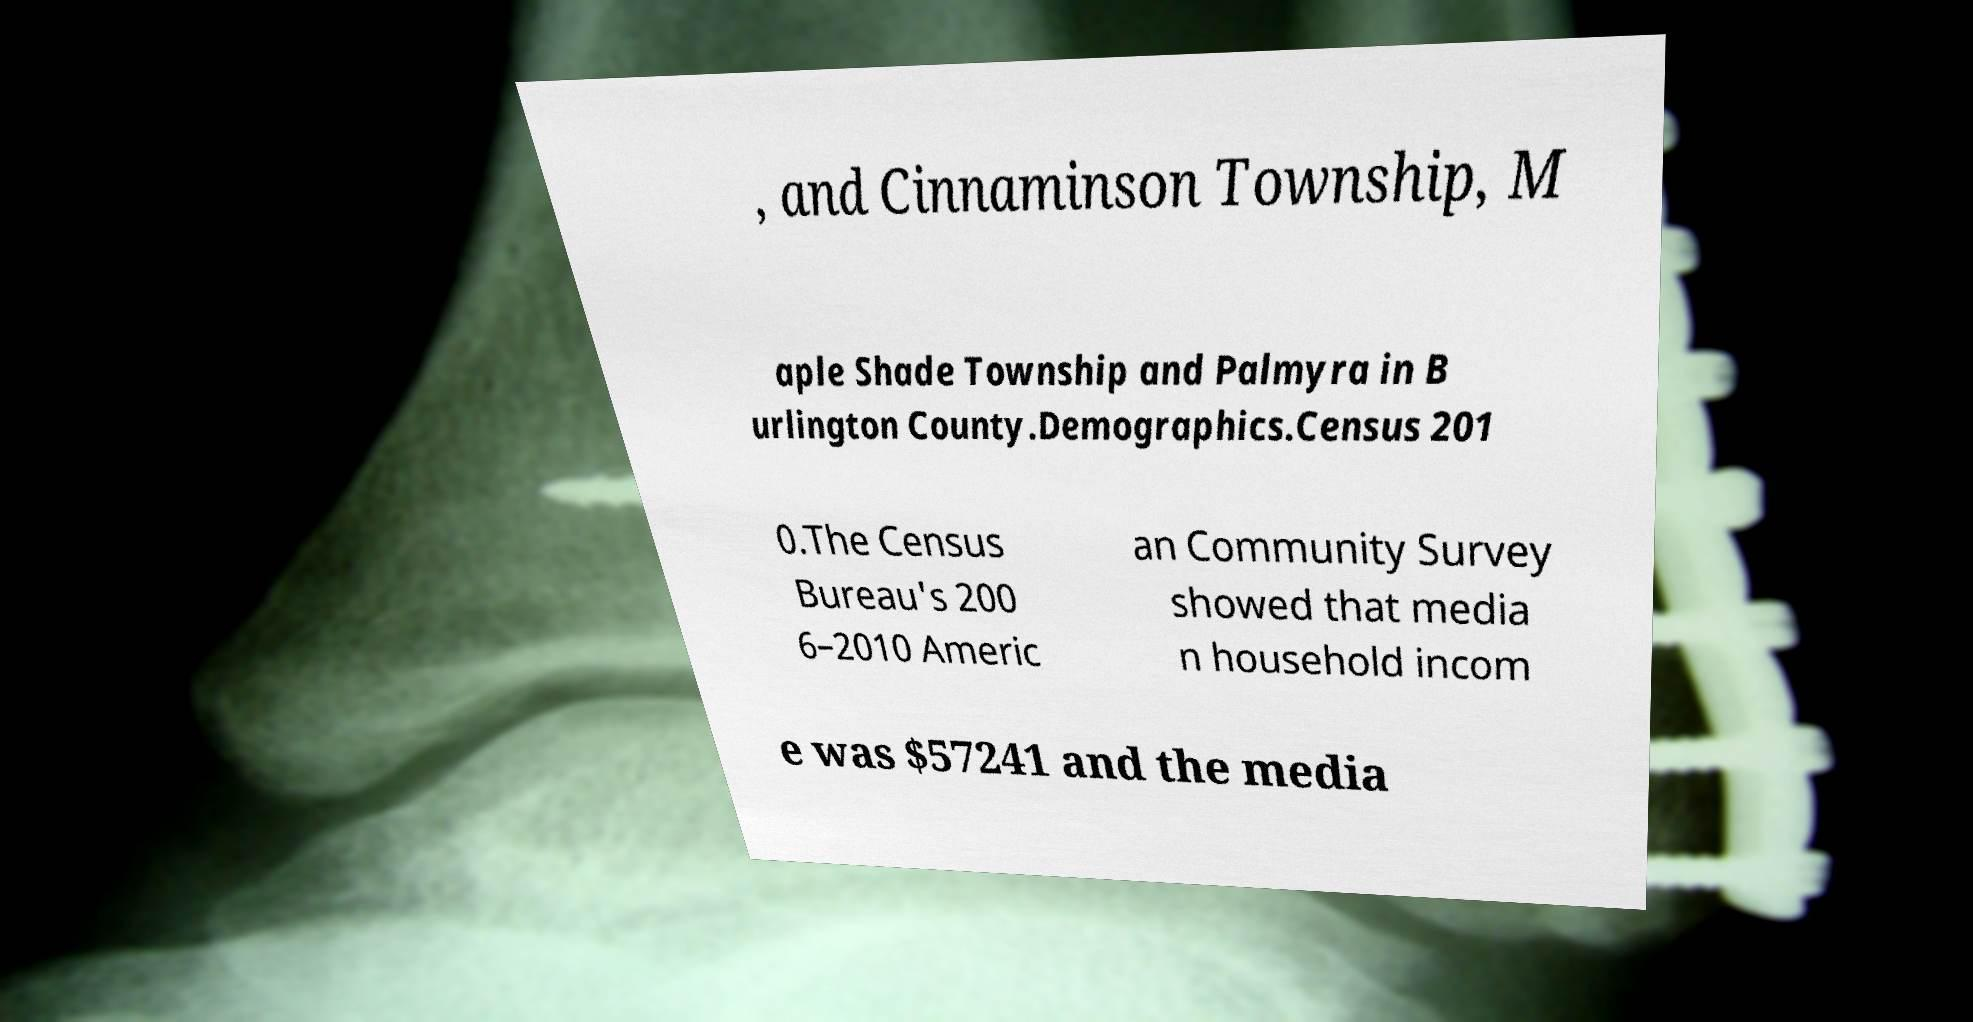Please read and relay the text visible in this image. What does it say? , and Cinnaminson Township, M aple Shade Township and Palmyra in B urlington County.Demographics.Census 201 0.The Census Bureau's 200 6–2010 Americ an Community Survey showed that media n household incom e was $57241 and the media 